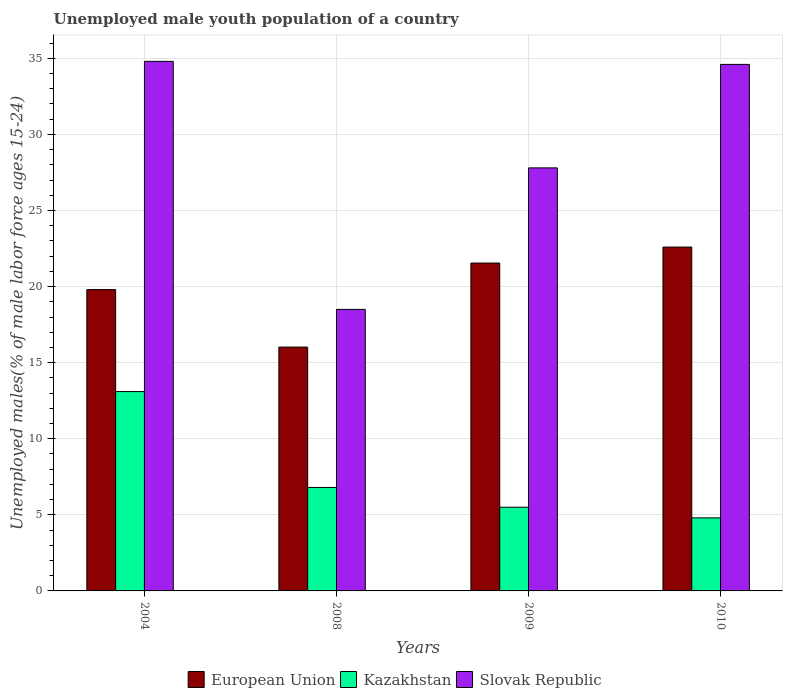How many different coloured bars are there?
Offer a terse response. 3. How many groups of bars are there?
Keep it short and to the point. 4. What is the percentage of unemployed male youth population in Kazakhstan in 2008?
Make the answer very short. 6.8. Across all years, what is the maximum percentage of unemployed male youth population in Kazakhstan?
Make the answer very short. 13.1. Across all years, what is the minimum percentage of unemployed male youth population in Kazakhstan?
Keep it short and to the point. 4.8. In which year was the percentage of unemployed male youth population in Slovak Republic maximum?
Ensure brevity in your answer.  2004. What is the total percentage of unemployed male youth population in Kazakhstan in the graph?
Provide a succinct answer. 30.2. What is the difference between the percentage of unemployed male youth population in Slovak Republic in 2008 and that in 2009?
Offer a very short reply. -9.3. What is the difference between the percentage of unemployed male youth population in Kazakhstan in 2008 and the percentage of unemployed male youth population in European Union in 2010?
Ensure brevity in your answer.  -15.8. What is the average percentage of unemployed male youth population in Kazakhstan per year?
Your answer should be very brief. 7.55. In the year 2008, what is the difference between the percentage of unemployed male youth population in European Union and percentage of unemployed male youth population in Kazakhstan?
Keep it short and to the point. 9.22. What is the ratio of the percentage of unemployed male youth population in Slovak Republic in 2004 to that in 2010?
Keep it short and to the point. 1.01. Is the difference between the percentage of unemployed male youth population in European Union in 2008 and 2009 greater than the difference between the percentage of unemployed male youth population in Kazakhstan in 2008 and 2009?
Provide a succinct answer. No. What is the difference between the highest and the second highest percentage of unemployed male youth population in Slovak Republic?
Your answer should be very brief. 0.2. What is the difference between the highest and the lowest percentage of unemployed male youth population in Kazakhstan?
Give a very brief answer. 8.3. In how many years, is the percentage of unemployed male youth population in Slovak Republic greater than the average percentage of unemployed male youth population in Slovak Republic taken over all years?
Offer a terse response. 2. What does the 1st bar from the left in 2009 represents?
Give a very brief answer. European Union. What does the 1st bar from the right in 2010 represents?
Your answer should be very brief. Slovak Republic. Is it the case that in every year, the sum of the percentage of unemployed male youth population in Slovak Republic and percentage of unemployed male youth population in European Union is greater than the percentage of unemployed male youth population in Kazakhstan?
Provide a succinct answer. Yes. How many years are there in the graph?
Offer a very short reply. 4. What is the difference between two consecutive major ticks on the Y-axis?
Give a very brief answer. 5. Are the values on the major ticks of Y-axis written in scientific E-notation?
Make the answer very short. No. Does the graph contain any zero values?
Keep it short and to the point. No. How many legend labels are there?
Make the answer very short. 3. What is the title of the graph?
Your response must be concise. Unemployed male youth population of a country. What is the label or title of the X-axis?
Keep it short and to the point. Years. What is the label or title of the Y-axis?
Your response must be concise. Unemployed males(% of male labor force ages 15-24). What is the Unemployed males(% of male labor force ages 15-24) of European Union in 2004?
Ensure brevity in your answer.  19.8. What is the Unemployed males(% of male labor force ages 15-24) in Kazakhstan in 2004?
Make the answer very short. 13.1. What is the Unemployed males(% of male labor force ages 15-24) in Slovak Republic in 2004?
Ensure brevity in your answer.  34.8. What is the Unemployed males(% of male labor force ages 15-24) in European Union in 2008?
Give a very brief answer. 16.02. What is the Unemployed males(% of male labor force ages 15-24) of Kazakhstan in 2008?
Your answer should be very brief. 6.8. What is the Unemployed males(% of male labor force ages 15-24) in Slovak Republic in 2008?
Give a very brief answer. 18.5. What is the Unemployed males(% of male labor force ages 15-24) in European Union in 2009?
Provide a short and direct response. 21.55. What is the Unemployed males(% of male labor force ages 15-24) in Slovak Republic in 2009?
Ensure brevity in your answer.  27.8. What is the Unemployed males(% of male labor force ages 15-24) in European Union in 2010?
Provide a short and direct response. 22.6. What is the Unemployed males(% of male labor force ages 15-24) of Kazakhstan in 2010?
Keep it short and to the point. 4.8. What is the Unemployed males(% of male labor force ages 15-24) in Slovak Republic in 2010?
Your response must be concise. 34.6. Across all years, what is the maximum Unemployed males(% of male labor force ages 15-24) in European Union?
Provide a succinct answer. 22.6. Across all years, what is the maximum Unemployed males(% of male labor force ages 15-24) in Kazakhstan?
Keep it short and to the point. 13.1. Across all years, what is the maximum Unemployed males(% of male labor force ages 15-24) of Slovak Republic?
Offer a very short reply. 34.8. Across all years, what is the minimum Unemployed males(% of male labor force ages 15-24) of European Union?
Ensure brevity in your answer.  16.02. Across all years, what is the minimum Unemployed males(% of male labor force ages 15-24) of Kazakhstan?
Offer a terse response. 4.8. Across all years, what is the minimum Unemployed males(% of male labor force ages 15-24) in Slovak Republic?
Give a very brief answer. 18.5. What is the total Unemployed males(% of male labor force ages 15-24) in European Union in the graph?
Your response must be concise. 79.97. What is the total Unemployed males(% of male labor force ages 15-24) in Kazakhstan in the graph?
Offer a very short reply. 30.2. What is the total Unemployed males(% of male labor force ages 15-24) of Slovak Republic in the graph?
Ensure brevity in your answer.  115.7. What is the difference between the Unemployed males(% of male labor force ages 15-24) of European Union in 2004 and that in 2008?
Your answer should be compact. 3.78. What is the difference between the Unemployed males(% of male labor force ages 15-24) in Kazakhstan in 2004 and that in 2008?
Your answer should be compact. 6.3. What is the difference between the Unemployed males(% of male labor force ages 15-24) in Slovak Republic in 2004 and that in 2008?
Give a very brief answer. 16.3. What is the difference between the Unemployed males(% of male labor force ages 15-24) of European Union in 2004 and that in 2009?
Provide a succinct answer. -1.74. What is the difference between the Unemployed males(% of male labor force ages 15-24) of Kazakhstan in 2004 and that in 2009?
Make the answer very short. 7.6. What is the difference between the Unemployed males(% of male labor force ages 15-24) of Slovak Republic in 2004 and that in 2009?
Give a very brief answer. 7. What is the difference between the Unemployed males(% of male labor force ages 15-24) in European Union in 2004 and that in 2010?
Provide a succinct answer. -2.8. What is the difference between the Unemployed males(% of male labor force ages 15-24) of Kazakhstan in 2004 and that in 2010?
Make the answer very short. 8.3. What is the difference between the Unemployed males(% of male labor force ages 15-24) in Slovak Republic in 2004 and that in 2010?
Your answer should be very brief. 0.2. What is the difference between the Unemployed males(% of male labor force ages 15-24) in European Union in 2008 and that in 2009?
Offer a terse response. -5.52. What is the difference between the Unemployed males(% of male labor force ages 15-24) in Kazakhstan in 2008 and that in 2009?
Give a very brief answer. 1.3. What is the difference between the Unemployed males(% of male labor force ages 15-24) of Slovak Republic in 2008 and that in 2009?
Your answer should be very brief. -9.3. What is the difference between the Unemployed males(% of male labor force ages 15-24) in European Union in 2008 and that in 2010?
Your response must be concise. -6.57. What is the difference between the Unemployed males(% of male labor force ages 15-24) of Kazakhstan in 2008 and that in 2010?
Give a very brief answer. 2. What is the difference between the Unemployed males(% of male labor force ages 15-24) in Slovak Republic in 2008 and that in 2010?
Give a very brief answer. -16.1. What is the difference between the Unemployed males(% of male labor force ages 15-24) of European Union in 2009 and that in 2010?
Provide a succinct answer. -1.05. What is the difference between the Unemployed males(% of male labor force ages 15-24) in Slovak Republic in 2009 and that in 2010?
Keep it short and to the point. -6.8. What is the difference between the Unemployed males(% of male labor force ages 15-24) in European Union in 2004 and the Unemployed males(% of male labor force ages 15-24) in Kazakhstan in 2008?
Offer a very short reply. 13. What is the difference between the Unemployed males(% of male labor force ages 15-24) in European Union in 2004 and the Unemployed males(% of male labor force ages 15-24) in Slovak Republic in 2008?
Your answer should be compact. 1.3. What is the difference between the Unemployed males(% of male labor force ages 15-24) in Kazakhstan in 2004 and the Unemployed males(% of male labor force ages 15-24) in Slovak Republic in 2008?
Offer a terse response. -5.4. What is the difference between the Unemployed males(% of male labor force ages 15-24) in European Union in 2004 and the Unemployed males(% of male labor force ages 15-24) in Kazakhstan in 2009?
Provide a succinct answer. 14.3. What is the difference between the Unemployed males(% of male labor force ages 15-24) of European Union in 2004 and the Unemployed males(% of male labor force ages 15-24) of Slovak Republic in 2009?
Your answer should be compact. -8. What is the difference between the Unemployed males(% of male labor force ages 15-24) of Kazakhstan in 2004 and the Unemployed males(% of male labor force ages 15-24) of Slovak Republic in 2009?
Offer a very short reply. -14.7. What is the difference between the Unemployed males(% of male labor force ages 15-24) in European Union in 2004 and the Unemployed males(% of male labor force ages 15-24) in Kazakhstan in 2010?
Provide a short and direct response. 15. What is the difference between the Unemployed males(% of male labor force ages 15-24) of European Union in 2004 and the Unemployed males(% of male labor force ages 15-24) of Slovak Republic in 2010?
Ensure brevity in your answer.  -14.8. What is the difference between the Unemployed males(% of male labor force ages 15-24) in Kazakhstan in 2004 and the Unemployed males(% of male labor force ages 15-24) in Slovak Republic in 2010?
Your answer should be compact. -21.5. What is the difference between the Unemployed males(% of male labor force ages 15-24) in European Union in 2008 and the Unemployed males(% of male labor force ages 15-24) in Kazakhstan in 2009?
Ensure brevity in your answer.  10.52. What is the difference between the Unemployed males(% of male labor force ages 15-24) in European Union in 2008 and the Unemployed males(% of male labor force ages 15-24) in Slovak Republic in 2009?
Offer a terse response. -11.78. What is the difference between the Unemployed males(% of male labor force ages 15-24) in Kazakhstan in 2008 and the Unemployed males(% of male labor force ages 15-24) in Slovak Republic in 2009?
Offer a very short reply. -21. What is the difference between the Unemployed males(% of male labor force ages 15-24) of European Union in 2008 and the Unemployed males(% of male labor force ages 15-24) of Kazakhstan in 2010?
Offer a terse response. 11.22. What is the difference between the Unemployed males(% of male labor force ages 15-24) in European Union in 2008 and the Unemployed males(% of male labor force ages 15-24) in Slovak Republic in 2010?
Keep it short and to the point. -18.58. What is the difference between the Unemployed males(% of male labor force ages 15-24) in Kazakhstan in 2008 and the Unemployed males(% of male labor force ages 15-24) in Slovak Republic in 2010?
Provide a short and direct response. -27.8. What is the difference between the Unemployed males(% of male labor force ages 15-24) of European Union in 2009 and the Unemployed males(% of male labor force ages 15-24) of Kazakhstan in 2010?
Provide a short and direct response. 16.75. What is the difference between the Unemployed males(% of male labor force ages 15-24) of European Union in 2009 and the Unemployed males(% of male labor force ages 15-24) of Slovak Republic in 2010?
Ensure brevity in your answer.  -13.05. What is the difference between the Unemployed males(% of male labor force ages 15-24) in Kazakhstan in 2009 and the Unemployed males(% of male labor force ages 15-24) in Slovak Republic in 2010?
Your answer should be very brief. -29.1. What is the average Unemployed males(% of male labor force ages 15-24) of European Union per year?
Make the answer very short. 19.99. What is the average Unemployed males(% of male labor force ages 15-24) of Kazakhstan per year?
Your response must be concise. 7.55. What is the average Unemployed males(% of male labor force ages 15-24) of Slovak Republic per year?
Offer a very short reply. 28.93. In the year 2004, what is the difference between the Unemployed males(% of male labor force ages 15-24) in European Union and Unemployed males(% of male labor force ages 15-24) in Kazakhstan?
Offer a terse response. 6.7. In the year 2004, what is the difference between the Unemployed males(% of male labor force ages 15-24) of European Union and Unemployed males(% of male labor force ages 15-24) of Slovak Republic?
Provide a short and direct response. -15. In the year 2004, what is the difference between the Unemployed males(% of male labor force ages 15-24) of Kazakhstan and Unemployed males(% of male labor force ages 15-24) of Slovak Republic?
Your answer should be very brief. -21.7. In the year 2008, what is the difference between the Unemployed males(% of male labor force ages 15-24) in European Union and Unemployed males(% of male labor force ages 15-24) in Kazakhstan?
Ensure brevity in your answer.  9.22. In the year 2008, what is the difference between the Unemployed males(% of male labor force ages 15-24) in European Union and Unemployed males(% of male labor force ages 15-24) in Slovak Republic?
Your answer should be compact. -2.48. In the year 2008, what is the difference between the Unemployed males(% of male labor force ages 15-24) in Kazakhstan and Unemployed males(% of male labor force ages 15-24) in Slovak Republic?
Provide a short and direct response. -11.7. In the year 2009, what is the difference between the Unemployed males(% of male labor force ages 15-24) of European Union and Unemployed males(% of male labor force ages 15-24) of Kazakhstan?
Your answer should be compact. 16.05. In the year 2009, what is the difference between the Unemployed males(% of male labor force ages 15-24) in European Union and Unemployed males(% of male labor force ages 15-24) in Slovak Republic?
Your answer should be compact. -6.25. In the year 2009, what is the difference between the Unemployed males(% of male labor force ages 15-24) in Kazakhstan and Unemployed males(% of male labor force ages 15-24) in Slovak Republic?
Provide a short and direct response. -22.3. In the year 2010, what is the difference between the Unemployed males(% of male labor force ages 15-24) in European Union and Unemployed males(% of male labor force ages 15-24) in Kazakhstan?
Provide a succinct answer. 17.8. In the year 2010, what is the difference between the Unemployed males(% of male labor force ages 15-24) of European Union and Unemployed males(% of male labor force ages 15-24) of Slovak Republic?
Your response must be concise. -12. In the year 2010, what is the difference between the Unemployed males(% of male labor force ages 15-24) in Kazakhstan and Unemployed males(% of male labor force ages 15-24) in Slovak Republic?
Your response must be concise. -29.8. What is the ratio of the Unemployed males(% of male labor force ages 15-24) in European Union in 2004 to that in 2008?
Your response must be concise. 1.24. What is the ratio of the Unemployed males(% of male labor force ages 15-24) of Kazakhstan in 2004 to that in 2008?
Your answer should be very brief. 1.93. What is the ratio of the Unemployed males(% of male labor force ages 15-24) of Slovak Republic in 2004 to that in 2008?
Your response must be concise. 1.88. What is the ratio of the Unemployed males(% of male labor force ages 15-24) of European Union in 2004 to that in 2009?
Make the answer very short. 0.92. What is the ratio of the Unemployed males(% of male labor force ages 15-24) in Kazakhstan in 2004 to that in 2009?
Your answer should be very brief. 2.38. What is the ratio of the Unemployed males(% of male labor force ages 15-24) of Slovak Republic in 2004 to that in 2009?
Provide a succinct answer. 1.25. What is the ratio of the Unemployed males(% of male labor force ages 15-24) of European Union in 2004 to that in 2010?
Provide a succinct answer. 0.88. What is the ratio of the Unemployed males(% of male labor force ages 15-24) of Kazakhstan in 2004 to that in 2010?
Make the answer very short. 2.73. What is the ratio of the Unemployed males(% of male labor force ages 15-24) of Slovak Republic in 2004 to that in 2010?
Give a very brief answer. 1.01. What is the ratio of the Unemployed males(% of male labor force ages 15-24) of European Union in 2008 to that in 2009?
Ensure brevity in your answer.  0.74. What is the ratio of the Unemployed males(% of male labor force ages 15-24) in Kazakhstan in 2008 to that in 2009?
Give a very brief answer. 1.24. What is the ratio of the Unemployed males(% of male labor force ages 15-24) of Slovak Republic in 2008 to that in 2009?
Your answer should be very brief. 0.67. What is the ratio of the Unemployed males(% of male labor force ages 15-24) in European Union in 2008 to that in 2010?
Your response must be concise. 0.71. What is the ratio of the Unemployed males(% of male labor force ages 15-24) in Kazakhstan in 2008 to that in 2010?
Make the answer very short. 1.42. What is the ratio of the Unemployed males(% of male labor force ages 15-24) in Slovak Republic in 2008 to that in 2010?
Make the answer very short. 0.53. What is the ratio of the Unemployed males(% of male labor force ages 15-24) of European Union in 2009 to that in 2010?
Keep it short and to the point. 0.95. What is the ratio of the Unemployed males(% of male labor force ages 15-24) of Kazakhstan in 2009 to that in 2010?
Keep it short and to the point. 1.15. What is the ratio of the Unemployed males(% of male labor force ages 15-24) in Slovak Republic in 2009 to that in 2010?
Give a very brief answer. 0.8. What is the difference between the highest and the second highest Unemployed males(% of male labor force ages 15-24) in European Union?
Your response must be concise. 1.05. What is the difference between the highest and the second highest Unemployed males(% of male labor force ages 15-24) in Kazakhstan?
Provide a short and direct response. 6.3. What is the difference between the highest and the lowest Unemployed males(% of male labor force ages 15-24) of European Union?
Keep it short and to the point. 6.57. 